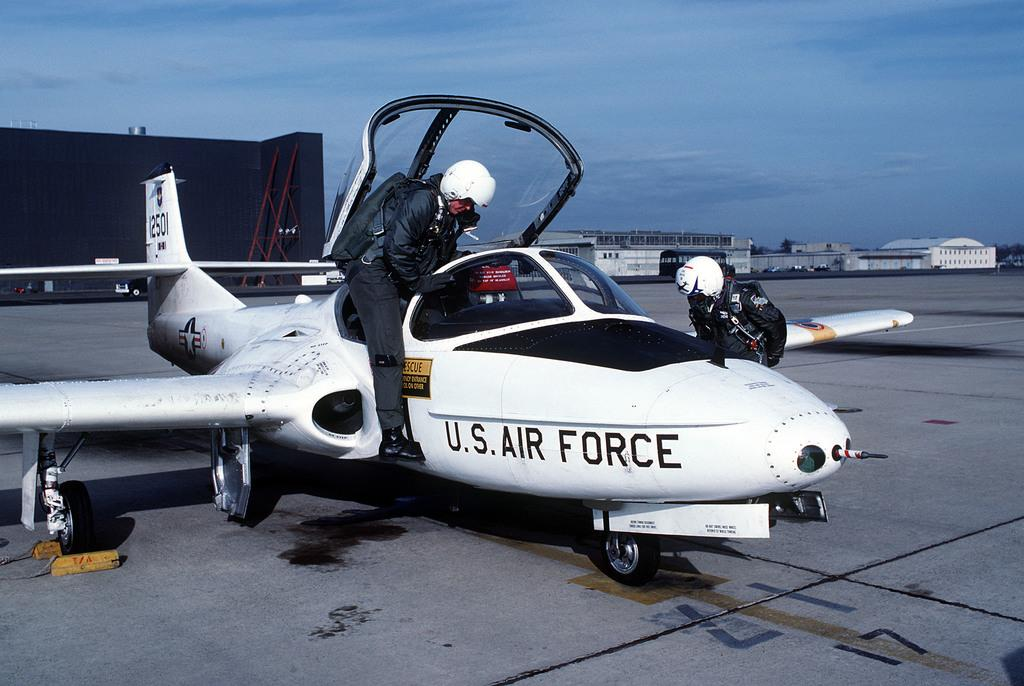<image>
Write a terse but informative summary of the picture. a us air force plane is being boarded by a pilot 